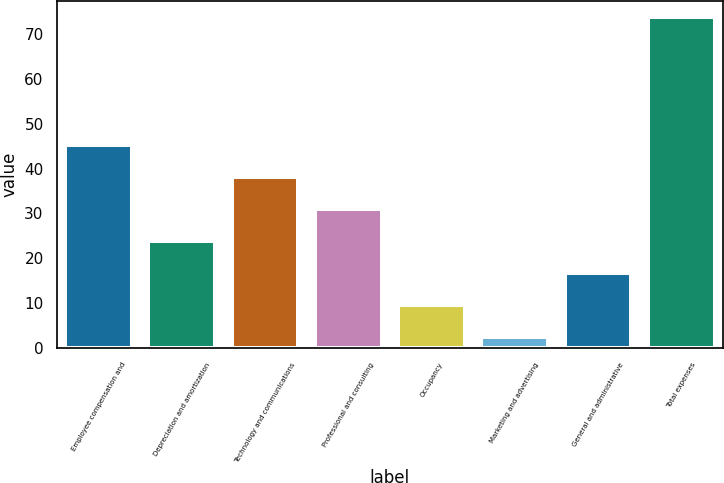<chart> <loc_0><loc_0><loc_500><loc_500><bar_chart><fcel>Employee compensation and<fcel>Depreciation and amortization<fcel>Technology and communications<fcel>Professional and consulting<fcel>Occupancy<fcel>Marketing and advertising<fcel>General and administrative<fcel>Total expenses<nl><fcel>45.22<fcel>23.86<fcel>38.1<fcel>30.98<fcel>9.62<fcel>2.5<fcel>16.74<fcel>73.7<nl></chart> 